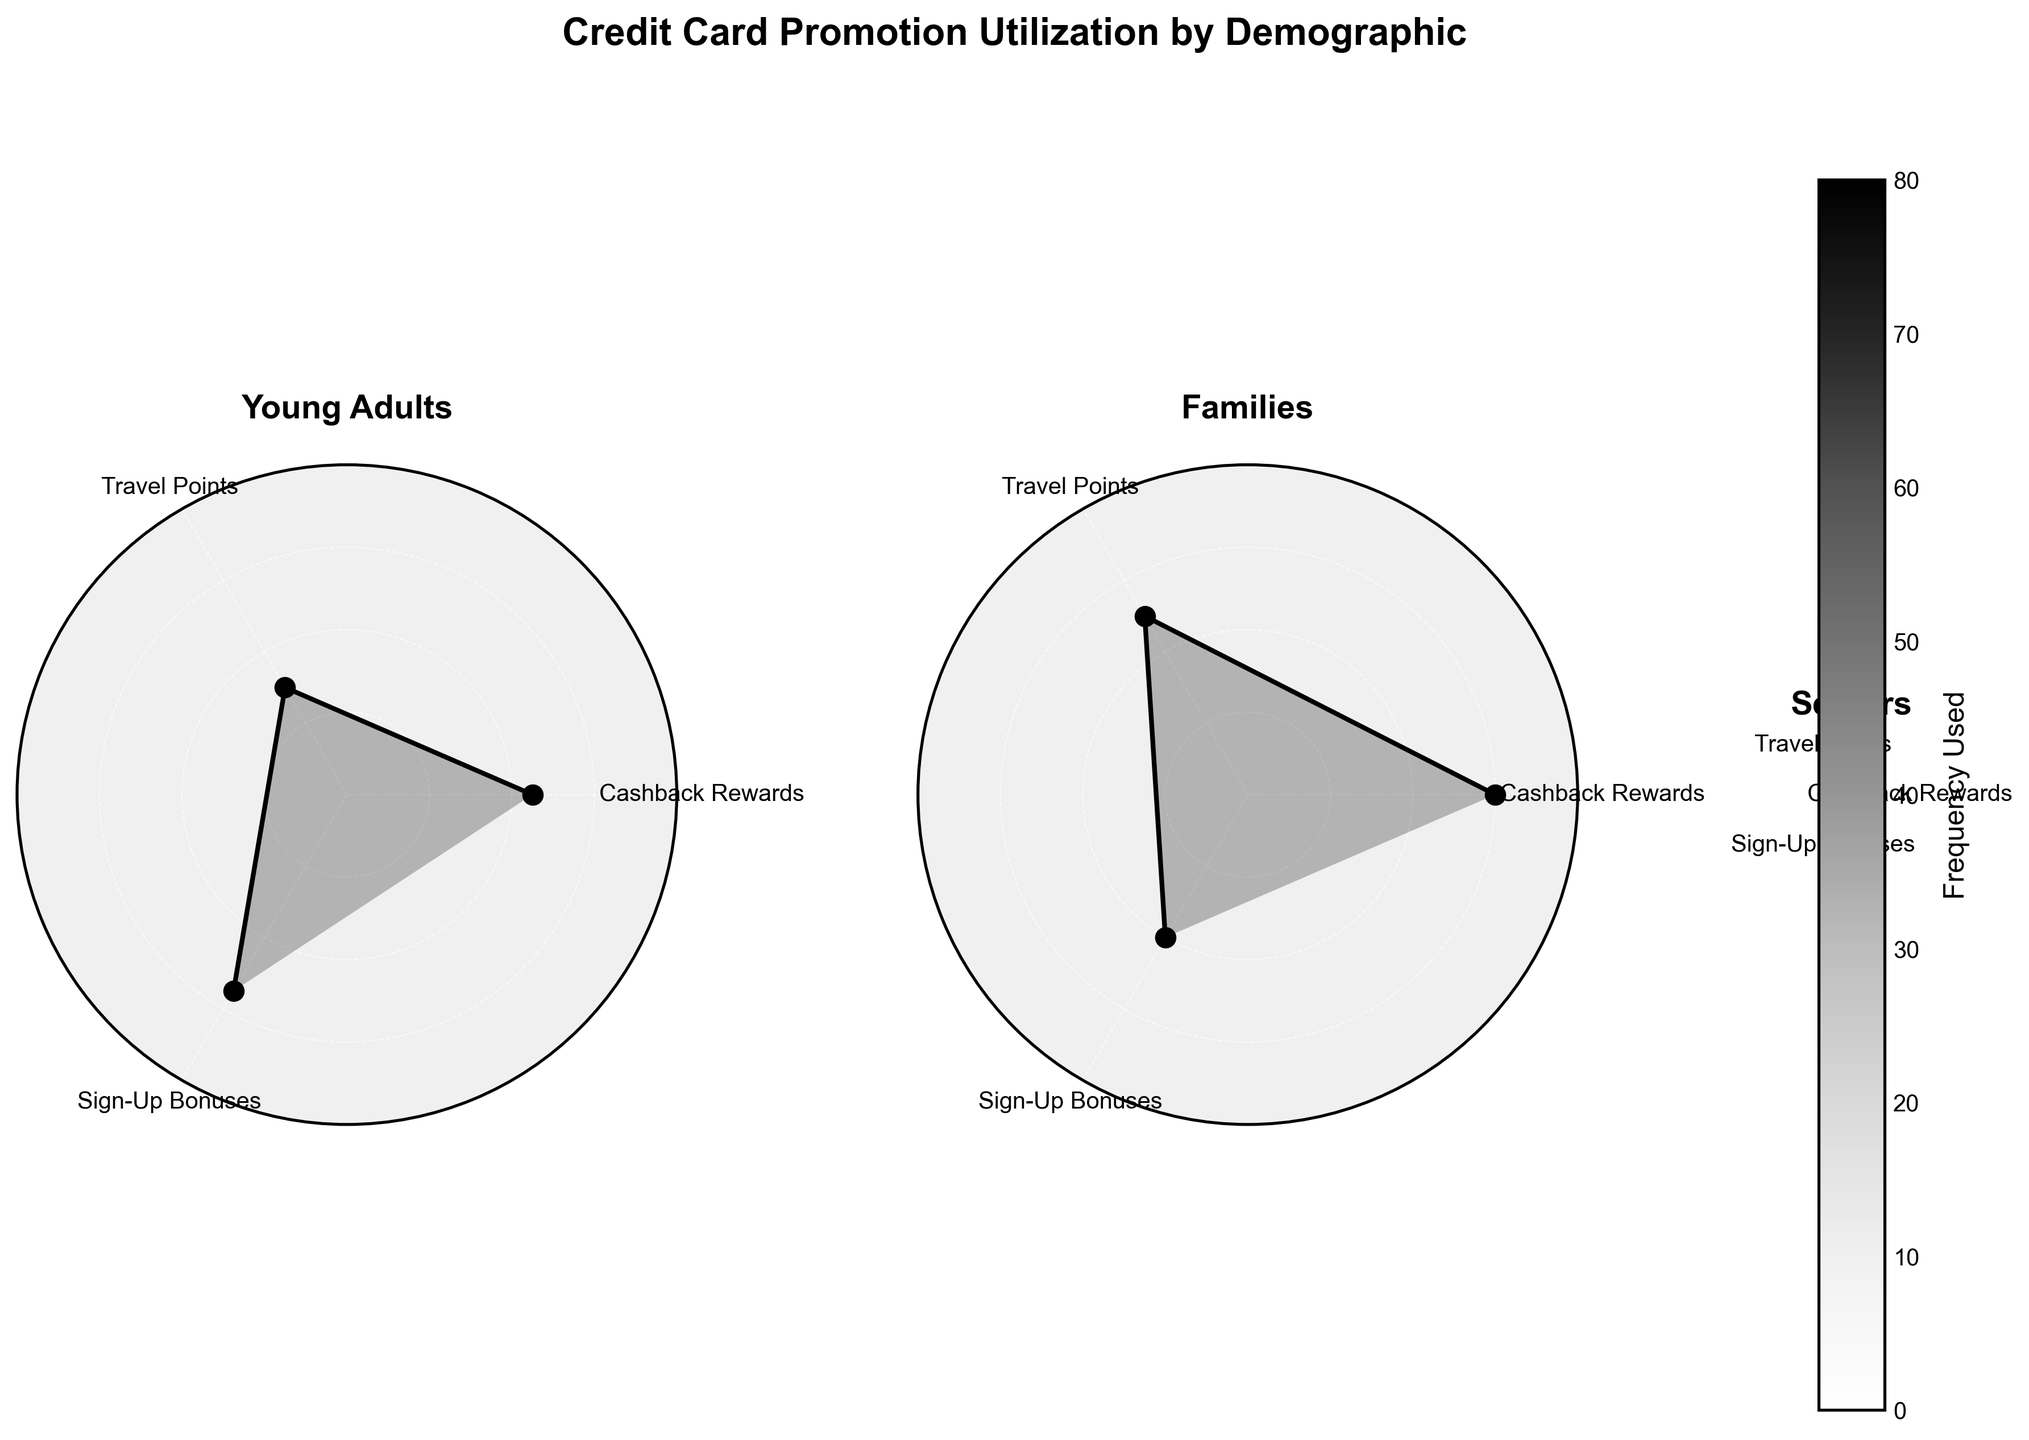Which demographic group utilizes Cashback Rewards the most? By looking at each group, we see that Seniors have the highest value for Cashback Rewards.
Answer: Seniors Which promotion type is utilized the most by Families? For Families, Cashback Rewards has the highest value compared to Travel Points and Sign-Up Bonuses.
Answer: Cashback Rewards What is the total frequency of Travel Points utilized across all demographic groups? Adding up the frequency values for Travel Points across all groups: Young Adults (30) + Families (50) + Seniors (25) = 105.
Answer: 105 Which demographic group utilizes Sign-Up Bonuses the least? By comparing the frequency values for Sign-Up Bonuses, Seniors have the lowest value.
Answer: Seniors What is the difference in utilization frequency between Cashback Rewards and Travel Points for Seniors? For Seniors, the Cashback Rewards frequency is 70 and the Travel Points frequency is 25. The difference is 70 - 25 = 45.
Answer: 45 Between Young Adults and Families, which group utilizes Travel Points more frequently? Comparing the Travel Points values, Families have a higher frequency (50) than Young Adults (30).
Answer: Families Which demographic group shows the highest variability in promotion types used? Families have high frequencies in Cashback Rewards and Travel Points, but a lower frequency in Sign-Up Bonuses, showing more variability.
Answer: Families How do the utilization frequencies for Young Adults' Sign-Up Bonuses and Seniors' Cashback Rewards compare? The frequency for Young Adults' Sign-Up Bonuses is 55, and for Seniors' Cashback Rewards, it is 70. Seniors' Cashback Rewards is higher.
Answer: Seniors' Cashback Rewards 